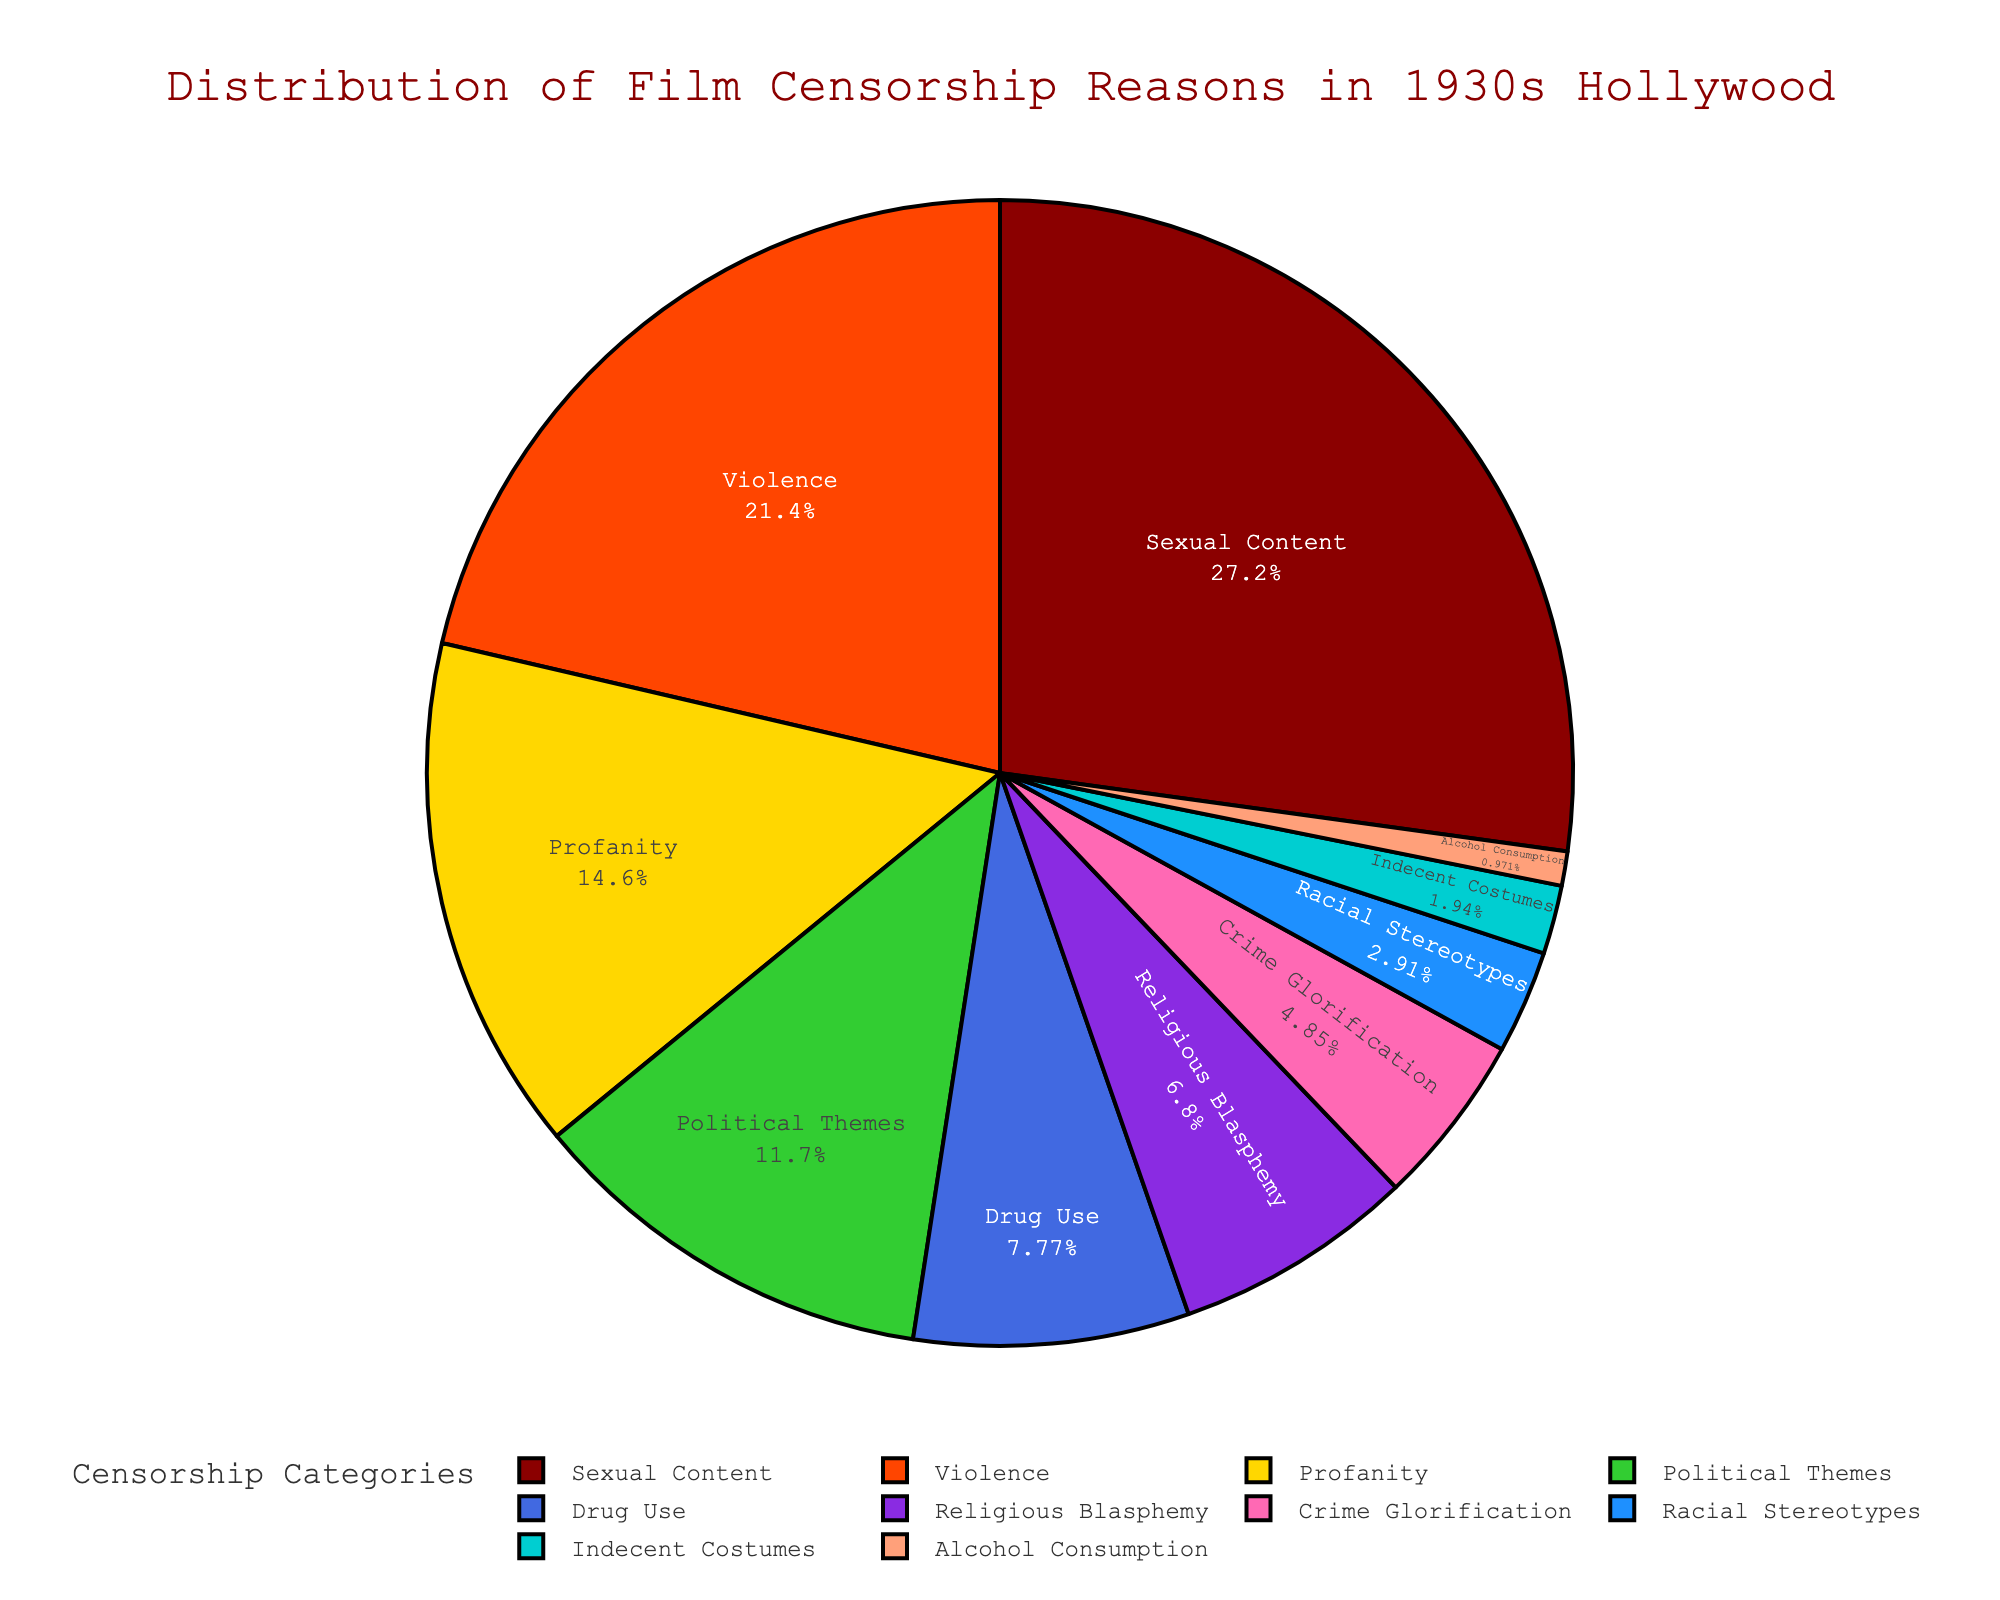Which category has the highest percentage of censorship reasons? The largest section of the pie chart is represented by 'Sexual Content'.
Answer: Sexual Content What is the combined percentage of 'Drug Use' and 'Religious Blasphemy'? Adding the percentages of 'Drug Use' (8%) and 'Religious Blasphemy' (7%) gives us 8 + 7 = 15%.
Answer: 15% How much larger is the percentage of 'Violence' compared to 'Crime Glorification'? The percentage for 'Violence' is 22%, and 'Crime Glorification' is 5%. The difference is 22 - 5 = 17%.
Answer: 17% Which two categories have the smallest percentages? The smallest sections of the pie chart are 'Indecent Costumes' (2%) and 'Alcohol Consumption' (1%).
Answer: Indecent Costumes and Alcohol Consumption What is the total percentage of censorship reasons related to 'Sexual Content', 'Profanity', and 'Drug Use'? Adding the percentages: 28% (Sexual Content) + 15% (Profanity) + 8% (Drug Use) = 51%.
Answer: 51% Is 'Political Themes' censored more or less than 'Violence'? 'Political Themes' (12%) is less than 'Violence' (22%).
Answer: Less What percentage of censorship reasons are related to 'Sexual Content' compared to 'Violence' and 'Profanity' combined? 'Sexual Content' is 28%. The sum of 'Violence' and 'Profanity' is 22% + 15% = 37%. 28% compared to 37%.
Answer: Less Which has a higher percentage, 'Religious Blasphemy' or 'Racial Stereotypes'? 'Religious Blasphemy' is 7% and 'Racial Stereotypes' is 3%. Thus, 'Religious Blasphemy' is higher.
Answer: Religious Blasphemy By how much does 'Sexual Content' exceed 'Political Themes'? 'Sexual Content' (28%) exceeds 'Political Themes' (12%) by 28 - 12 = 16%.
Answer: 16% What's the total percentage for the three least represented categories combined? The three least represented categories are 'Indecent Costumes' (2%), 'Alcohol Consumption' (1%), and 'Racial Stereotypes' (3%). Summing these gives 2 + 1 + 3 = 6%.
Answer: 6% 